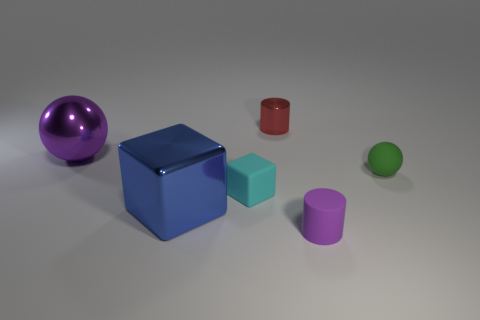What size is the blue thing that is the same shape as the cyan matte object?
Your answer should be very brief. Large. How many purple cylinders are made of the same material as the big sphere?
Make the answer very short. 0. What is the material of the big cube?
Offer a terse response. Metal. The small cyan thing that is on the right side of the thing that is to the left of the big metallic block is what shape?
Give a very brief answer. Cube. There is a large object that is behind the green sphere; what is its shape?
Your answer should be compact. Sphere. How many other matte balls are the same color as the rubber ball?
Provide a short and direct response. 0. The metallic cube has what color?
Give a very brief answer. Blue. There is a small cylinder that is in front of the big metallic block; how many tiny red things are behind it?
Provide a succinct answer. 1. There is a cyan rubber cube; is it the same size as the purple thing that is left of the blue metal object?
Your answer should be very brief. No. Does the cyan thing have the same size as the metallic cylinder?
Keep it short and to the point. Yes. 